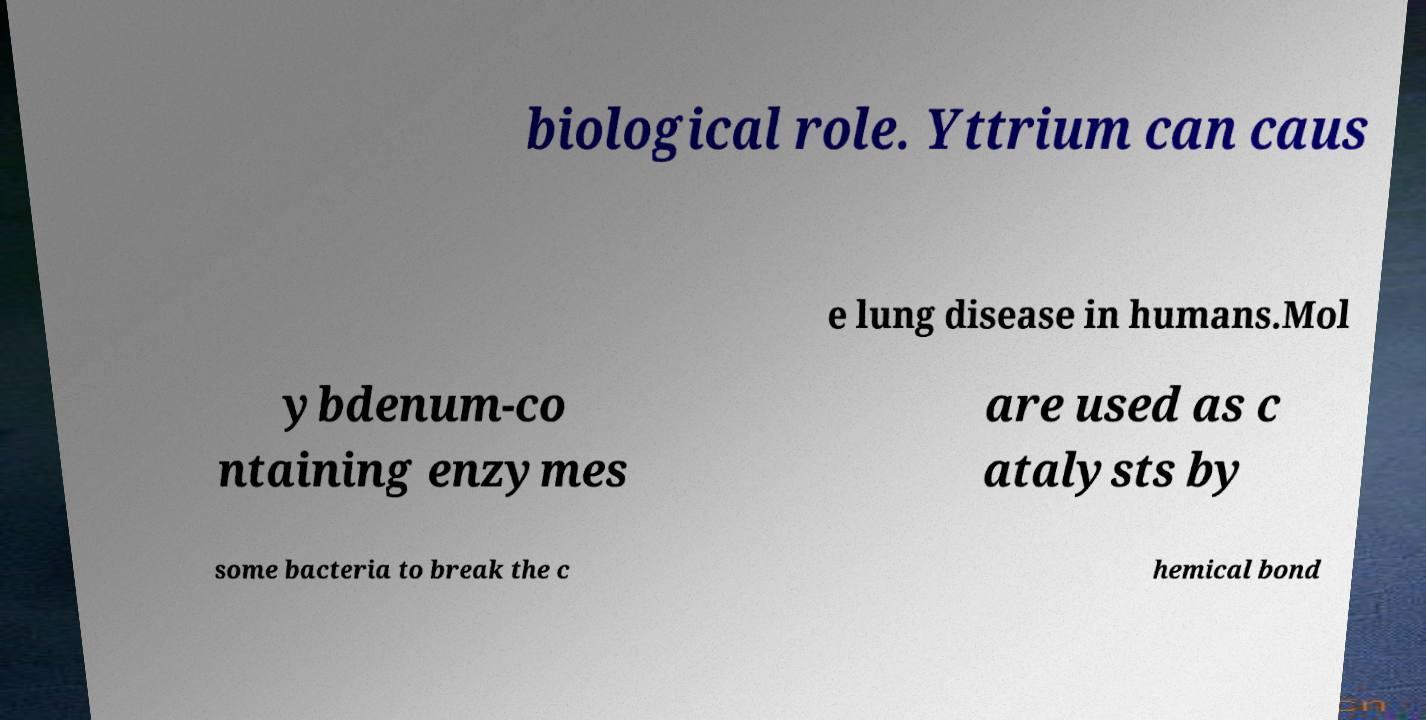Please read and relay the text visible in this image. What does it say? biological role. Yttrium can caus e lung disease in humans.Mol ybdenum-co ntaining enzymes are used as c atalysts by some bacteria to break the c hemical bond 